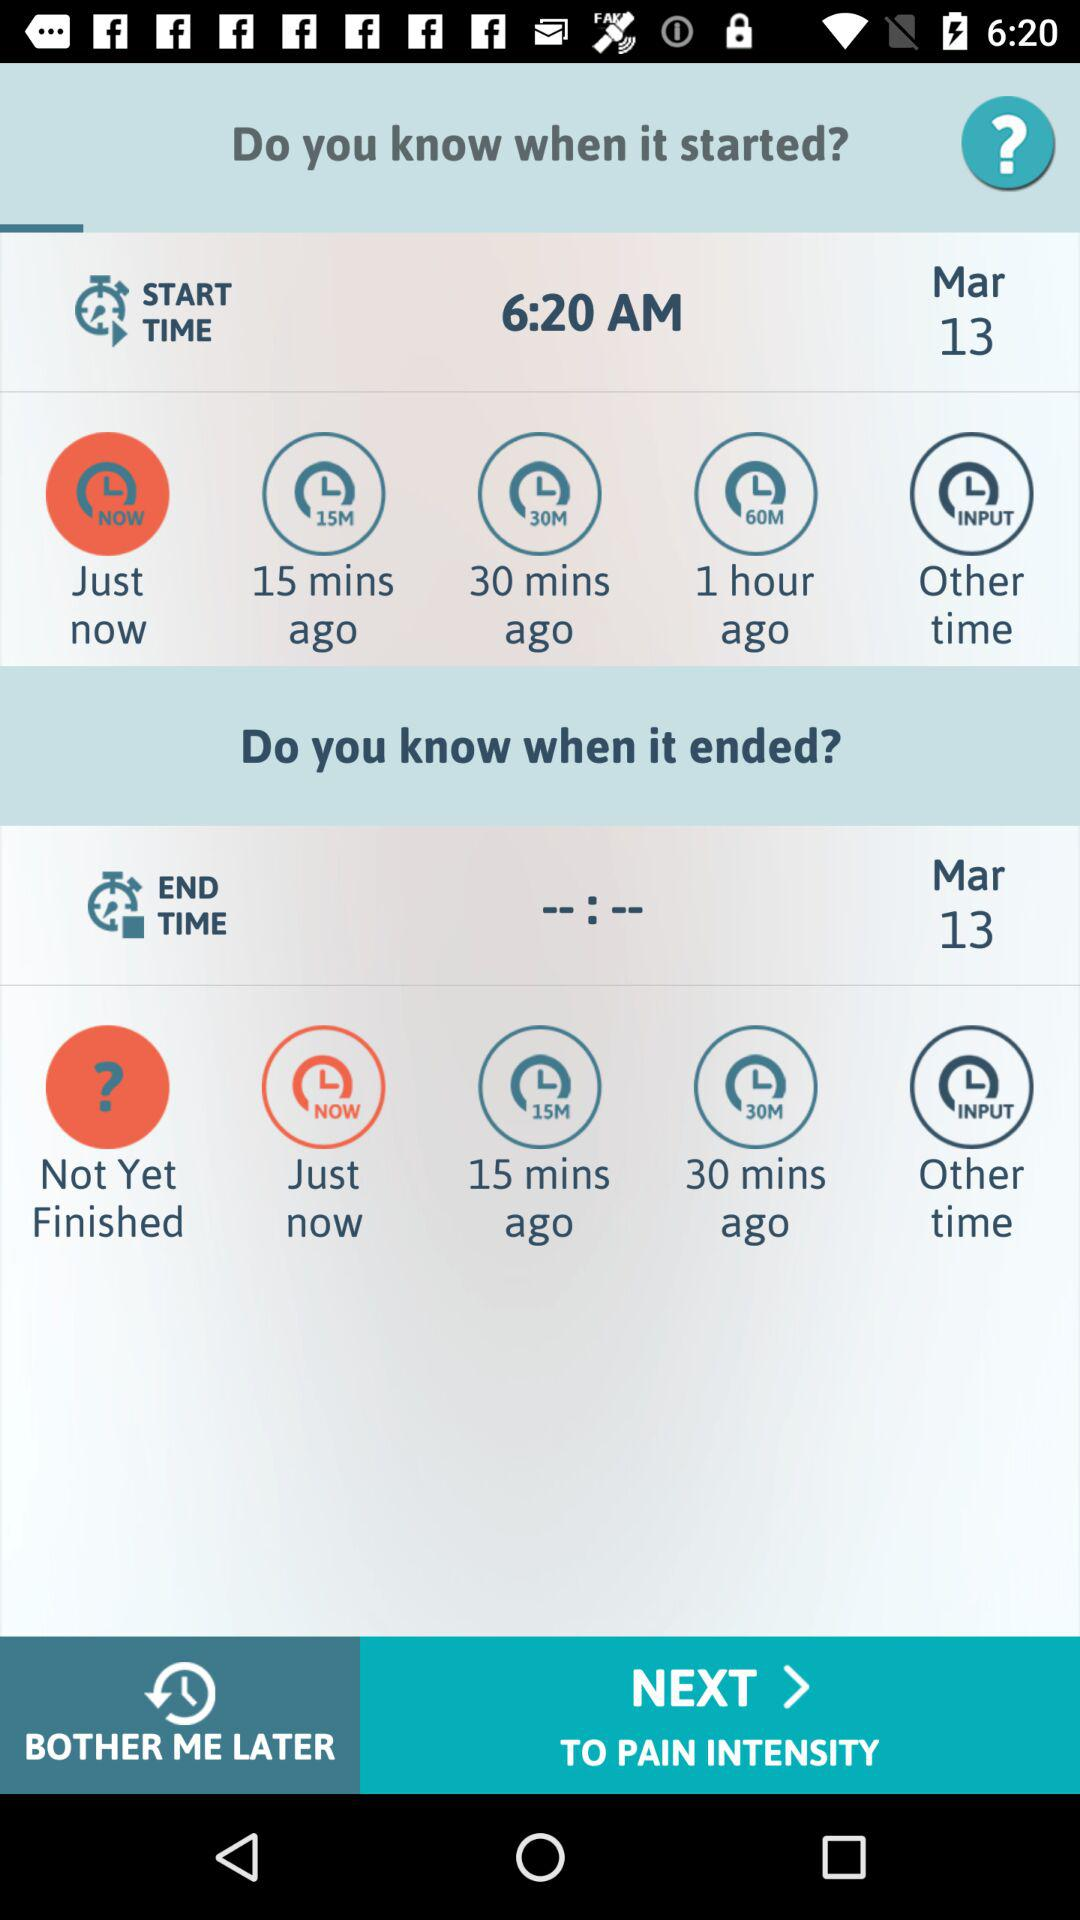What is the end date? The end date is March 13. 